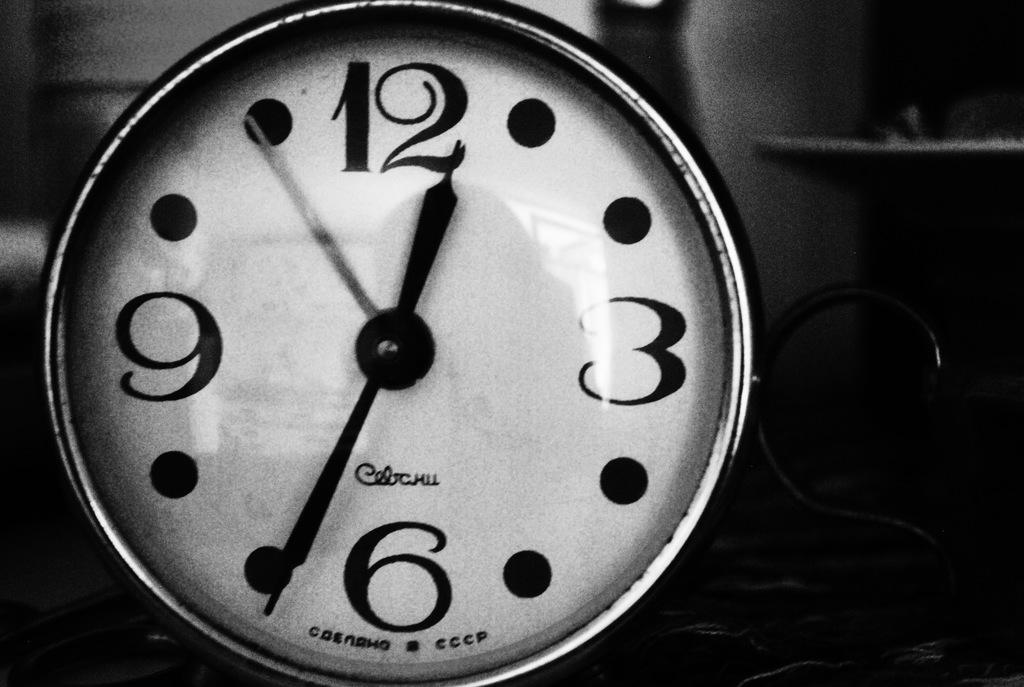What time does the clock read?
Your answer should be compact. 12:35. 